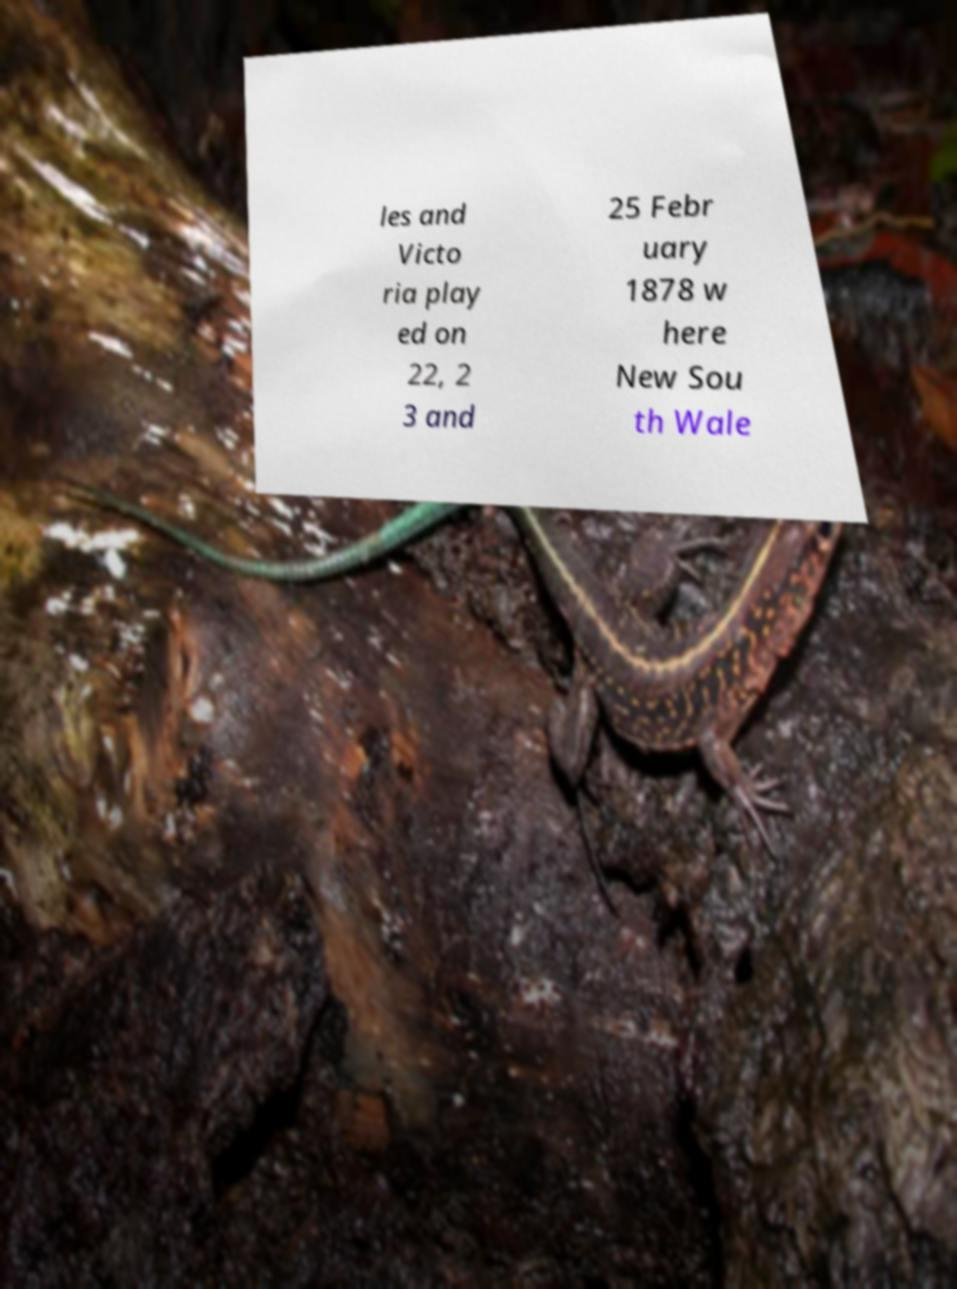I need the written content from this picture converted into text. Can you do that? les and Victo ria play ed on 22, 2 3 and 25 Febr uary 1878 w here New Sou th Wale 